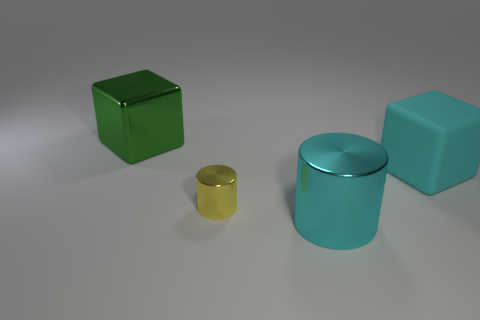Add 3 tiny blue metal objects. How many objects exist? 7 Subtract all tiny brown cubes. Subtract all small yellow metallic cylinders. How many objects are left? 3 Add 1 metallic objects. How many metallic objects are left? 4 Add 1 big cyan metal cylinders. How many big cyan metal cylinders exist? 2 Subtract 0 purple cylinders. How many objects are left? 4 